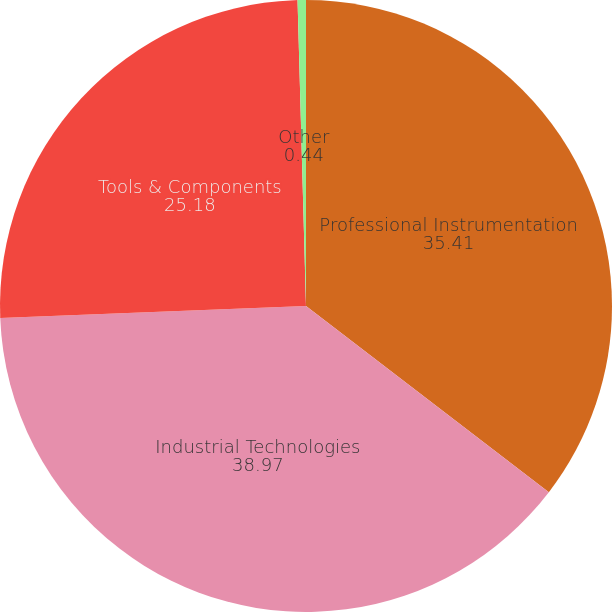<chart> <loc_0><loc_0><loc_500><loc_500><pie_chart><fcel>Professional Instrumentation<fcel>Industrial Technologies<fcel>Tools & Components<fcel>Other<nl><fcel>35.41%<fcel>38.97%<fcel>25.18%<fcel>0.44%<nl></chart> 